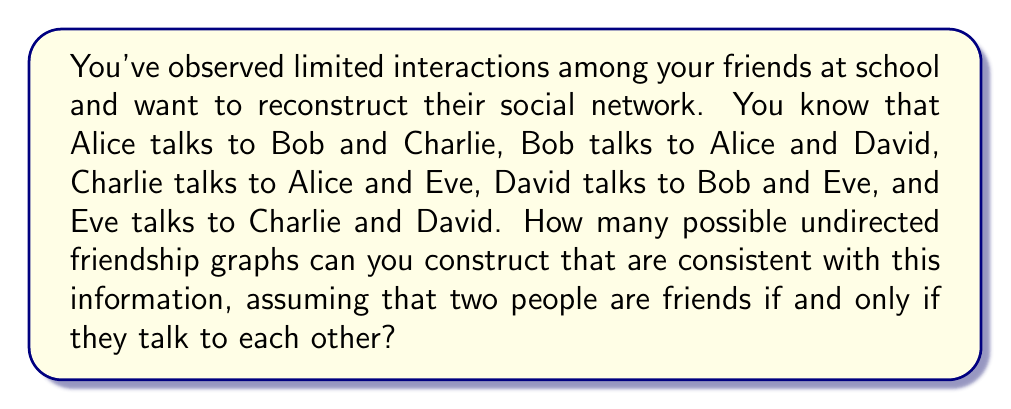What is the answer to this math problem? Let's approach this step-by-step:

1) First, we need to understand what we know for certain:
   - Alice is friends with Bob and Charlie
   - Bob is friends with Alice and David
   - Charlie is friends with Alice and Eve
   - David is friends with Bob and Eve
   - Eve is friends with Charlie and David

2) We can represent this as a graph where each person is a node and each friendship is an edge. The edges we know for certain are:
   Alice-Bob, Alice-Charlie, Bob-David, Charlie-Eve, David-Eve

3) The only uncertain relationship is between Bob and Charlie. They might be friends or not.

4) We can represent this mathematically using adjacency matrices. Let's number the people:
   1: Alice, 2: Bob, 3: Charlie, 4: David, 5: Eve

5) The adjacency matrix will look like this:

   $$
   \begin{pmatrix}
   0 & 1 & 1 & 0 & 0 \\
   1 & 0 & x & 1 & 0 \\
   1 & x & 0 & 0 & 1 \\
   0 & 1 & 0 & 0 & 1 \\
   0 & 0 & 1 & 1 & 0
   \end{pmatrix}
   $$

   Where $x$ can be either 0 or 1.

6) Therefore, there are two possible friendship graphs:
   - One where Bob and Charlie are not friends ($x = 0$)
   - One where Bob and Charlie are friends ($x = 1$)

Thus, there are 2 possible undirected friendship graphs consistent with the given information.
Answer: 2 